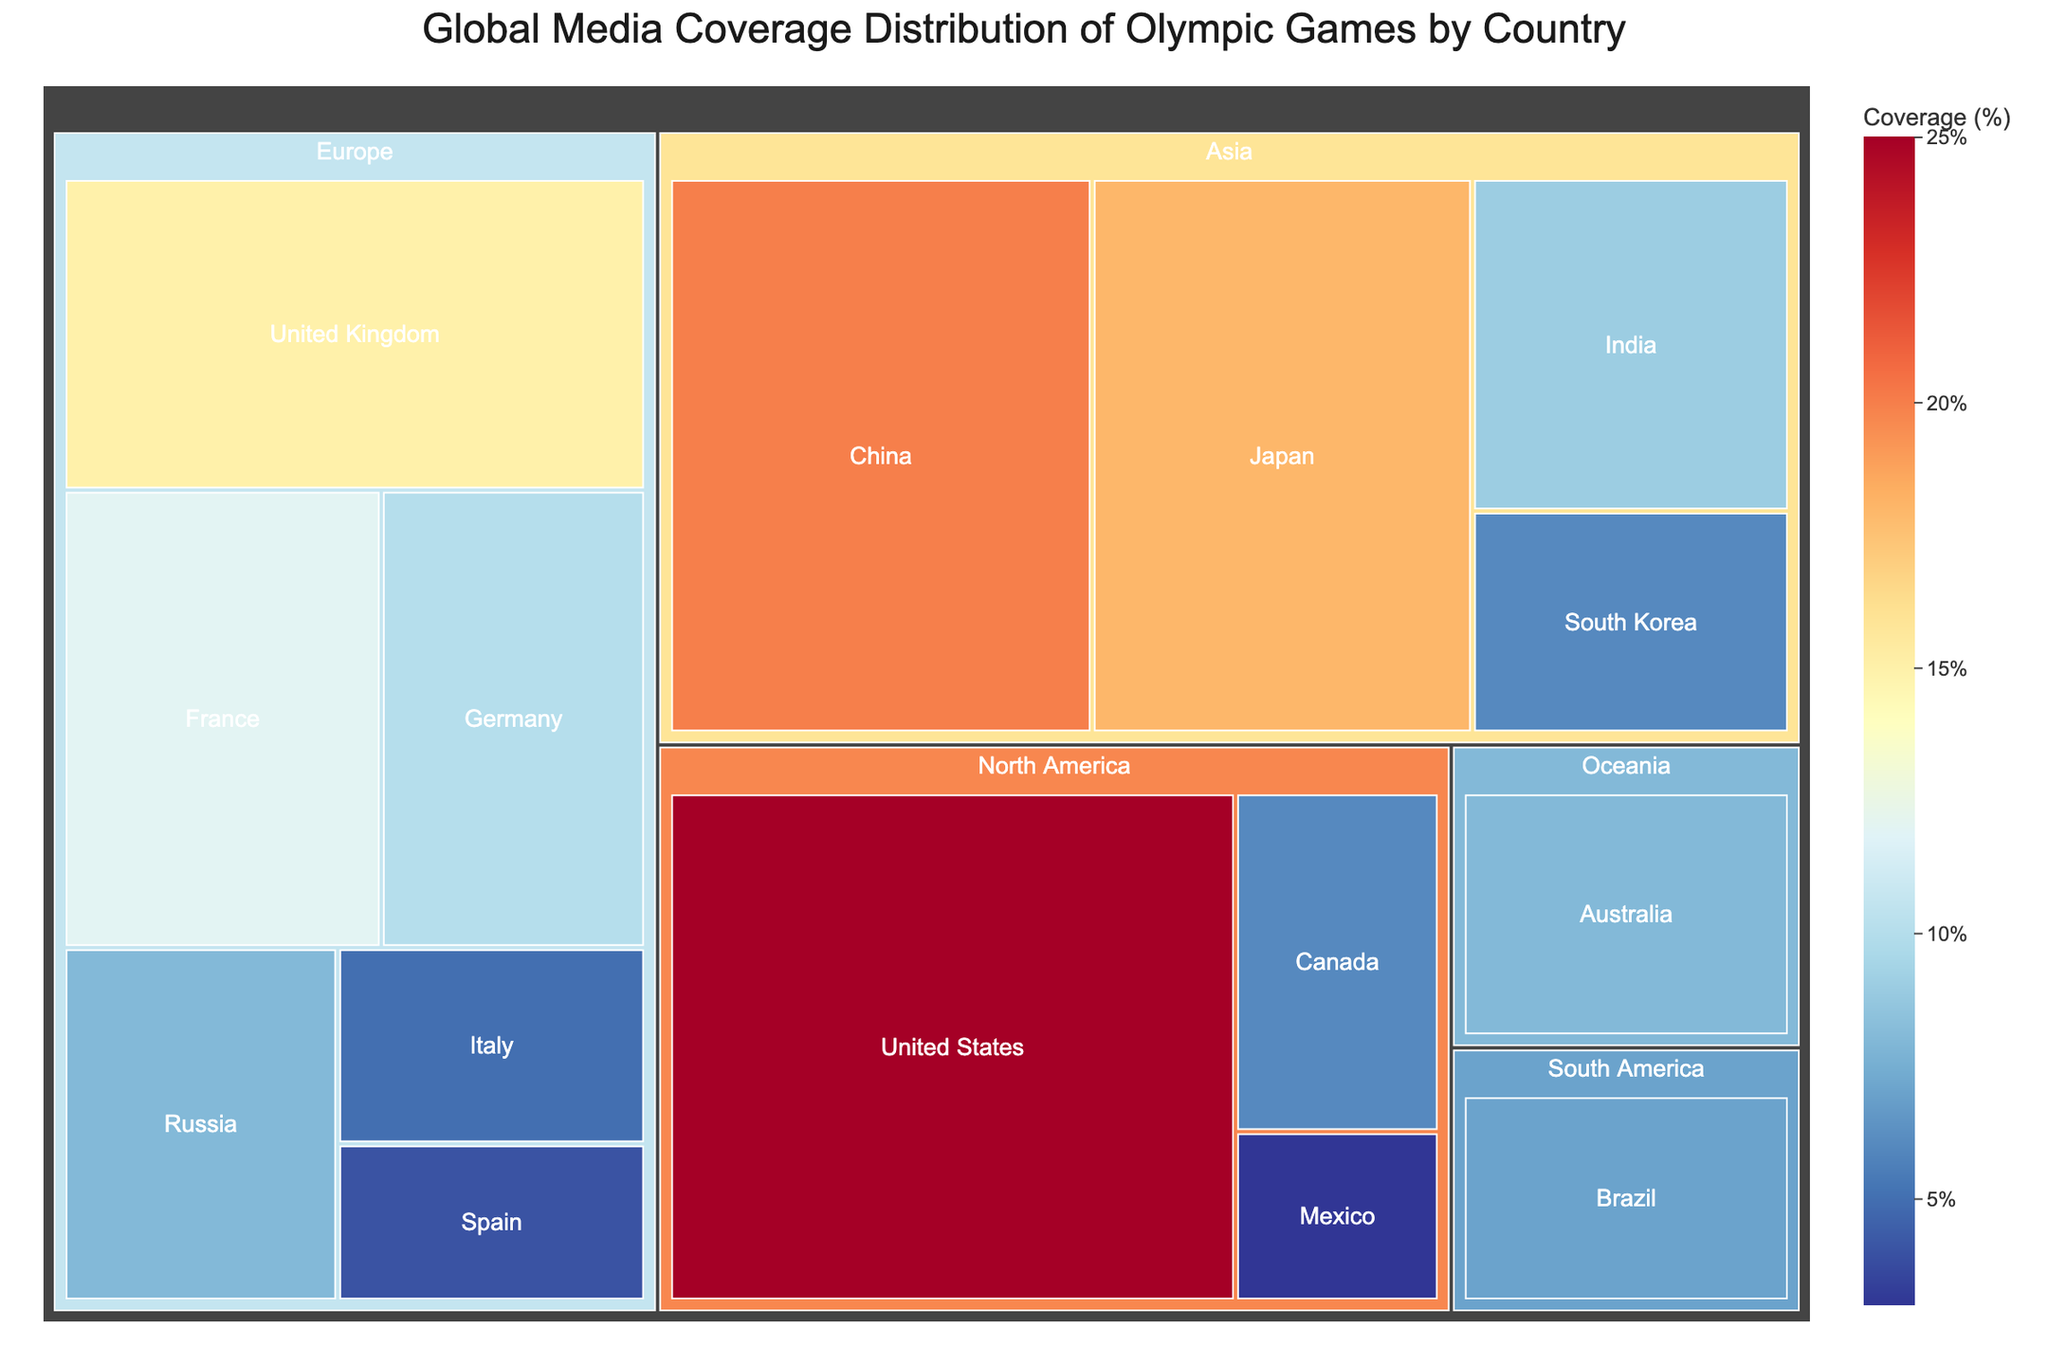Which country has the highest media coverage? The United States has the highest media coverage, as shown by the largest block in the treemap.
Answer: United States What is the total media coverage for all Asian countries combined? Sum the coverage values of Japan (18), China (20), India (9), and South Korea (6): 18 + 20 + 9 + 6 = 53.
Answer: 53 How does the media coverage of Canada compare to that of Mexico? The treemap shows that Canada has a coverage of 6%, while Mexico has a coverage of 3%. Canada’s coverage is 3% higher than Mexico's.
Answer: Canada has 3% higher coverage than Mexico Which country in Europe has the least media coverage? Spain has the least coverage in Europe with 4%, as shown by one of the smaller blocks in the European region of the treemap.
Answer: Spain What percentage of global media coverage is contributed by the United States and China combined? The media coverage for the United States is 25% and for China is 20%. Sum these to get the total: 25 + 20 = 45%.
Answer: 45% Compare the media coverage of South America to Oceania. South America, represented by Brazil, has 7% coverage. Oceania, represented by Australia, has 8% coverage. Comparing the two, Oceania has 1% more coverage than South America.
Answer: Oceania has 1% more coverage How many regions are represented in the treemap? The regions are North America, Europe, Asia, Oceania, and South America. Counting these, there are 5 regions represented.
Answer: 5 What is the average media coverage for European countries? European countries are the United Kingdom (15), France (12), Germany (10), Russia (8), Italy (5), and Spain (4). Sum these values and divide by the number of countries: (15 + 12 + 10 + 8 + 5 + 4) / 6 = 54 / 6 = 9.
Answer: 9 Does Japan have higher media coverage than Germany? Japan has 18% coverage while Germany has 10%. Thus, Japan has higher media coverage than Germany.
Answer: Yes What is the median coverage value of the countries listed? List all coverage values: 25, 20, 18, 15, 12, 10, 9, 8, 8, 7, 6, 6, 5, 4, 3. The median value of an odd number of data points (15 values) is the 8th value when sorted: 8.
Answer: 8 